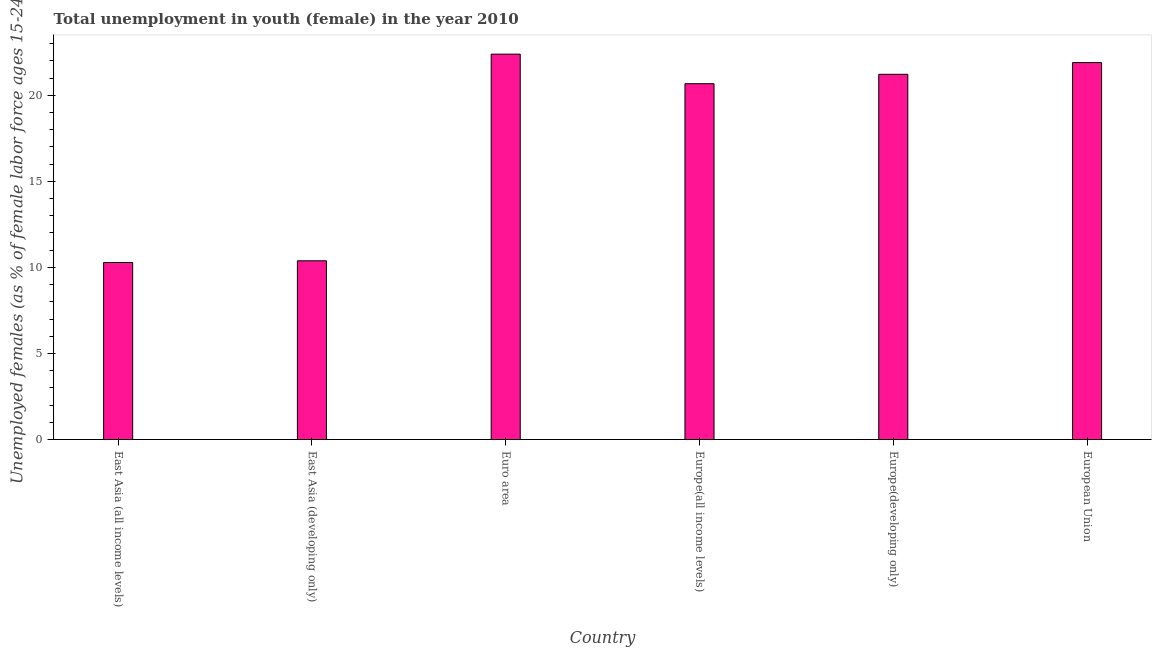Does the graph contain any zero values?
Offer a very short reply. No. Does the graph contain grids?
Provide a short and direct response. No. What is the title of the graph?
Provide a succinct answer. Total unemployment in youth (female) in the year 2010. What is the label or title of the X-axis?
Provide a short and direct response. Country. What is the label or title of the Y-axis?
Offer a very short reply. Unemployed females (as % of female labor force ages 15-24). What is the unemployed female youth population in Europe(developing only)?
Ensure brevity in your answer.  21.22. Across all countries, what is the maximum unemployed female youth population?
Ensure brevity in your answer.  22.39. Across all countries, what is the minimum unemployed female youth population?
Provide a short and direct response. 10.29. In which country was the unemployed female youth population minimum?
Give a very brief answer. East Asia (all income levels). What is the sum of the unemployed female youth population?
Your answer should be compact. 106.86. What is the difference between the unemployed female youth population in Europe(all income levels) and Europe(developing only)?
Your answer should be very brief. -0.55. What is the average unemployed female youth population per country?
Ensure brevity in your answer.  17.81. What is the median unemployed female youth population?
Your answer should be very brief. 20.95. In how many countries, is the unemployed female youth population greater than 16 %?
Offer a terse response. 4. What is the ratio of the unemployed female youth population in East Asia (all income levels) to that in Europe(all income levels)?
Provide a short and direct response. 0.5. Is the difference between the unemployed female youth population in East Asia (all income levels) and Euro area greater than the difference between any two countries?
Ensure brevity in your answer.  Yes. What is the difference between the highest and the second highest unemployed female youth population?
Offer a terse response. 0.49. What is the difference between the highest and the lowest unemployed female youth population?
Your answer should be compact. 12.11. In how many countries, is the unemployed female youth population greater than the average unemployed female youth population taken over all countries?
Your response must be concise. 4. How many bars are there?
Offer a terse response. 6. Are all the bars in the graph horizontal?
Keep it short and to the point. No. What is the Unemployed females (as % of female labor force ages 15-24) of East Asia (all income levels)?
Make the answer very short. 10.29. What is the Unemployed females (as % of female labor force ages 15-24) in East Asia (developing only)?
Keep it short and to the point. 10.38. What is the Unemployed females (as % of female labor force ages 15-24) of Euro area?
Give a very brief answer. 22.39. What is the Unemployed females (as % of female labor force ages 15-24) of Europe(all income levels)?
Make the answer very short. 20.67. What is the Unemployed females (as % of female labor force ages 15-24) of Europe(developing only)?
Keep it short and to the point. 21.22. What is the Unemployed females (as % of female labor force ages 15-24) of European Union?
Your answer should be compact. 21.9. What is the difference between the Unemployed females (as % of female labor force ages 15-24) in East Asia (all income levels) and East Asia (developing only)?
Keep it short and to the point. -0.1. What is the difference between the Unemployed females (as % of female labor force ages 15-24) in East Asia (all income levels) and Euro area?
Keep it short and to the point. -12.11. What is the difference between the Unemployed females (as % of female labor force ages 15-24) in East Asia (all income levels) and Europe(all income levels)?
Keep it short and to the point. -10.39. What is the difference between the Unemployed females (as % of female labor force ages 15-24) in East Asia (all income levels) and Europe(developing only)?
Your answer should be compact. -10.93. What is the difference between the Unemployed females (as % of female labor force ages 15-24) in East Asia (all income levels) and European Union?
Provide a short and direct response. -11.62. What is the difference between the Unemployed females (as % of female labor force ages 15-24) in East Asia (developing only) and Euro area?
Ensure brevity in your answer.  -12.01. What is the difference between the Unemployed females (as % of female labor force ages 15-24) in East Asia (developing only) and Europe(all income levels)?
Offer a very short reply. -10.29. What is the difference between the Unemployed females (as % of female labor force ages 15-24) in East Asia (developing only) and Europe(developing only)?
Ensure brevity in your answer.  -10.84. What is the difference between the Unemployed females (as % of female labor force ages 15-24) in East Asia (developing only) and European Union?
Your response must be concise. -11.52. What is the difference between the Unemployed females (as % of female labor force ages 15-24) in Euro area and Europe(all income levels)?
Ensure brevity in your answer.  1.72. What is the difference between the Unemployed females (as % of female labor force ages 15-24) in Euro area and Europe(developing only)?
Make the answer very short. 1.17. What is the difference between the Unemployed females (as % of female labor force ages 15-24) in Euro area and European Union?
Make the answer very short. 0.49. What is the difference between the Unemployed females (as % of female labor force ages 15-24) in Europe(all income levels) and Europe(developing only)?
Keep it short and to the point. -0.55. What is the difference between the Unemployed females (as % of female labor force ages 15-24) in Europe(all income levels) and European Union?
Give a very brief answer. -1.23. What is the difference between the Unemployed females (as % of female labor force ages 15-24) in Europe(developing only) and European Union?
Your answer should be very brief. -0.68. What is the ratio of the Unemployed females (as % of female labor force ages 15-24) in East Asia (all income levels) to that in East Asia (developing only)?
Make the answer very short. 0.99. What is the ratio of the Unemployed females (as % of female labor force ages 15-24) in East Asia (all income levels) to that in Euro area?
Keep it short and to the point. 0.46. What is the ratio of the Unemployed females (as % of female labor force ages 15-24) in East Asia (all income levels) to that in Europe(all income levels)?
Give a very brief answer. 0.5. What is the ratio of the Unemployed females (as % of female labor force ages 15-24) in East Asia (all income levels) to that in Europe(developing only)?
Keep it short and to the point. 0.48. What is the ratio of the Unemployed females (as % of female labor force ages 15-24) in East Asia (all income levels) to that in European Union?
Your response must be concise. 0.47. What is the ratio of the Unemployed females (as % of female labor force ages 15-24) in East Asia (developing only) to that in Euro area?
Ensure brevity in your answer.  0.46. What is the ratio of the Unemployed females (as % of female labor force ages 15-24) in East Asia (developing only) to that in Europe(all income levels)?
Give a very brief answer. 0.5. What is the ratio of the Unemployed females (as % of female labor force ages 15-24) in East Asia (developing only) to that in Europe(developing only)?
Keep it short and to the point. 0.49. What is the ratio of the Unemployed females (as % of female labor force ages 15-24) in East Asia (developing only) to that in European Union?
Offer a terse response. 0.47. What is the ratio of the Unemployed females (as % of female labor force ages 15-24) in Euro area to that in Europe(all income levels)?
Provide a short and direct response. 1.08. What is the ratio of the Unemployed females (as % of female labor force ages 15-24) in Euro area to that in Europe(developing only)?
Keep it short and to the point. 1.05. What is the ratio of the Unemployed females (as % of female labor force ages 15-24) in Euro area to that in European Union?
Provide a succinct answer. 1.02. What is the ratio of the Unemployed females (as % of female labor force ages 15-24) in Europe(all income levels) to that in Europe(developing only)?
Keep it short and to the point. 0.97. What is the ratio of the Unemployed females (as % of female labor force ages 15-24) in Europe(all income levels) to that in European Union?
Provide a short and direct response. 0.94. 